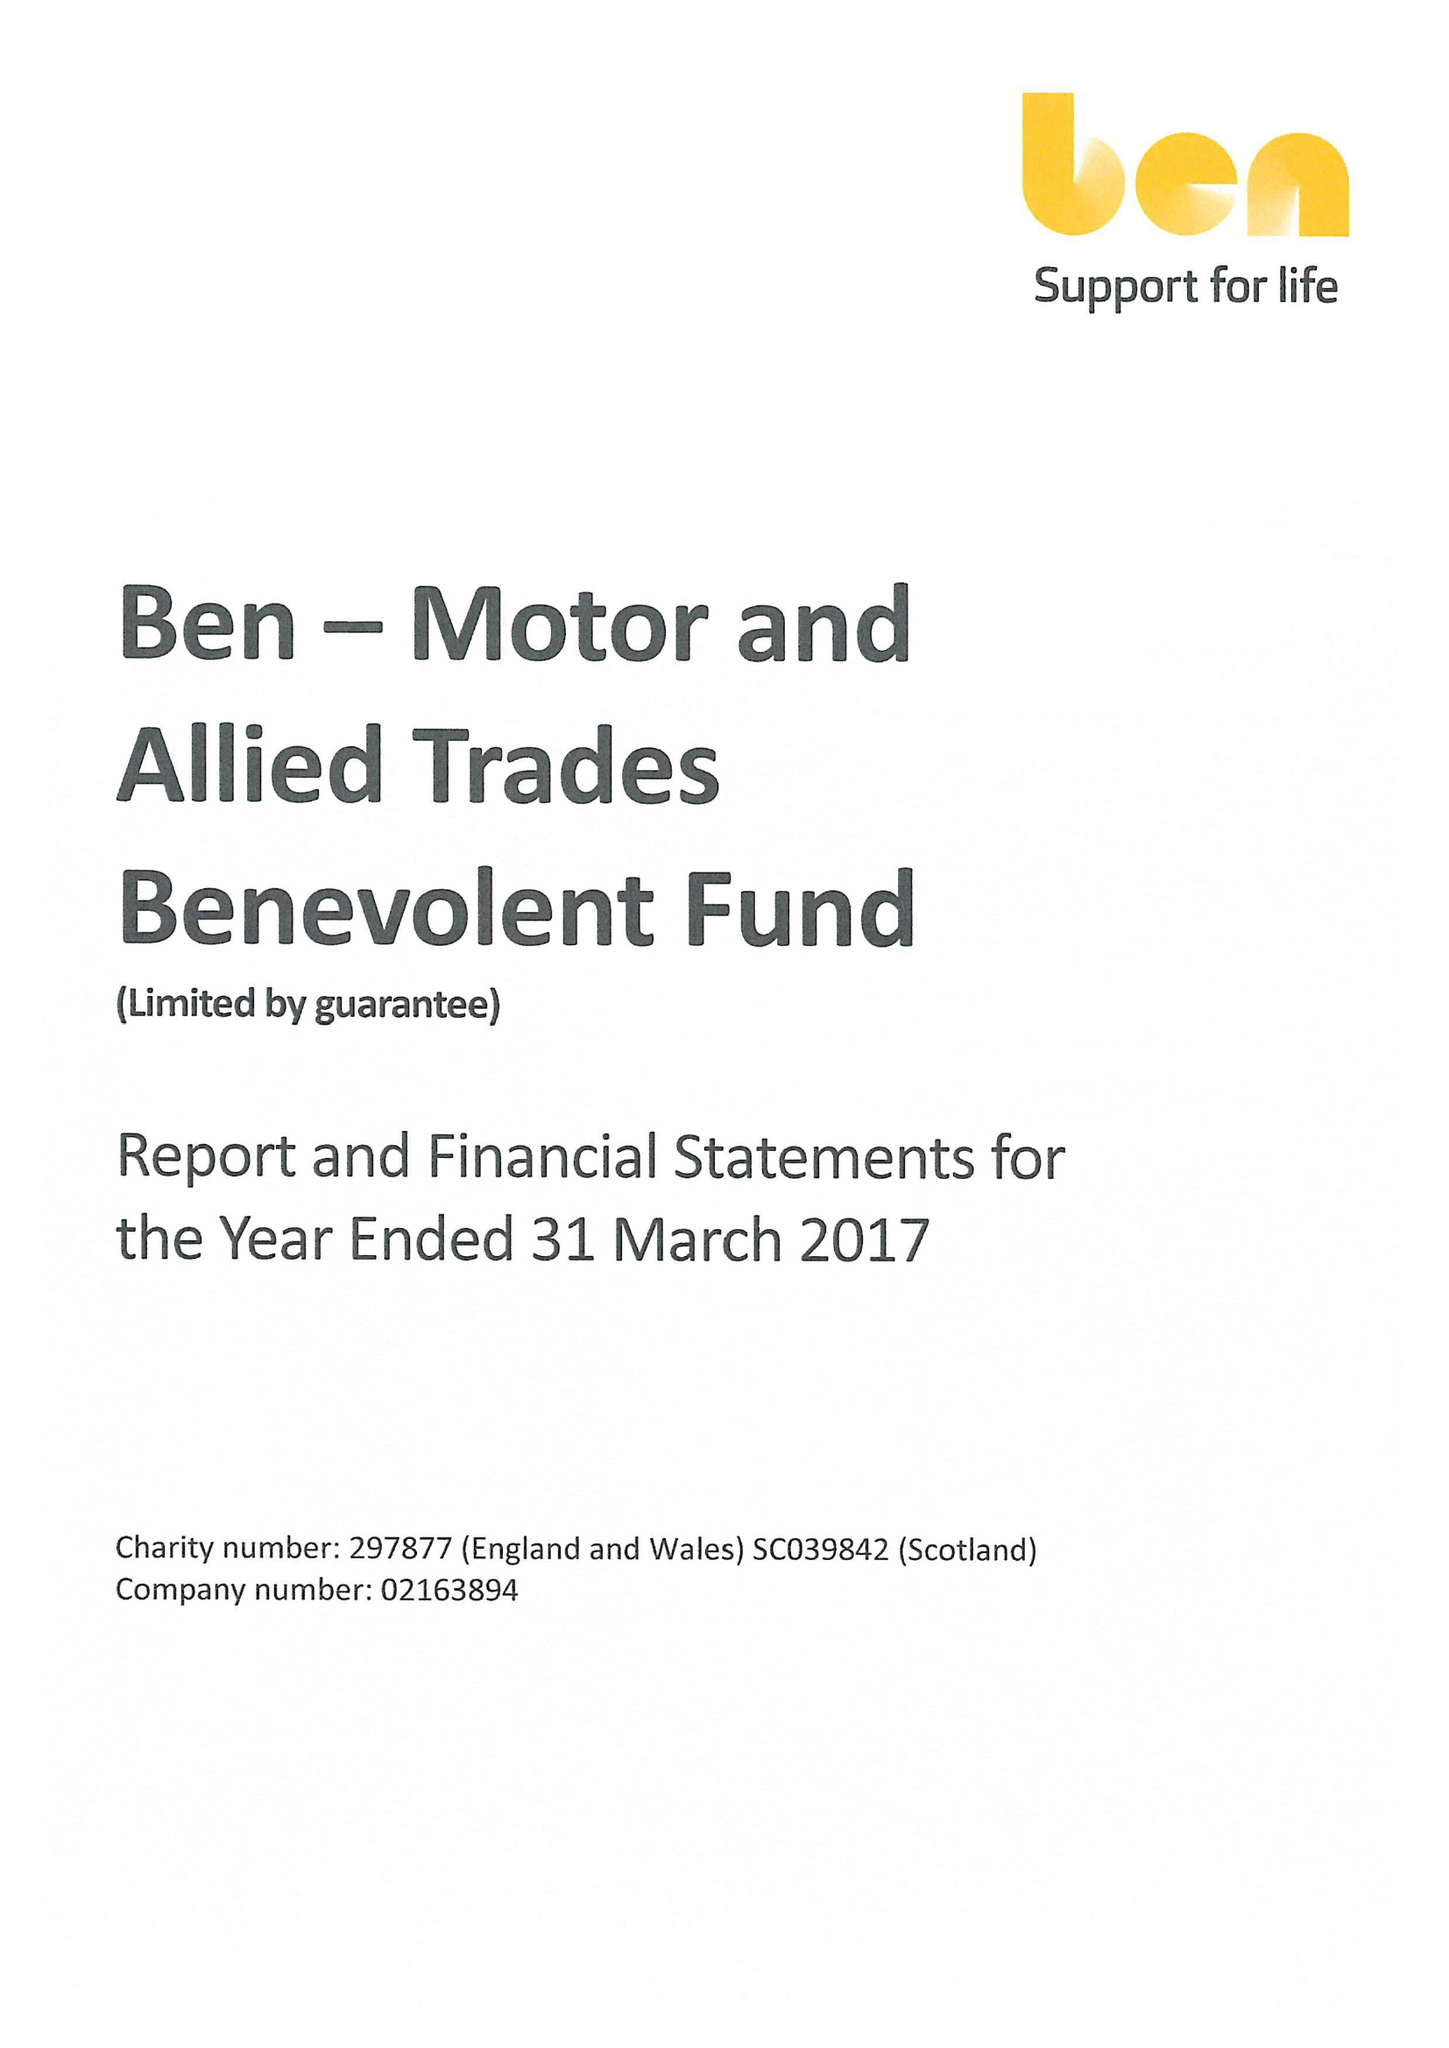What is the value for the charity_number?
Answer the question using a single word or phrase. 297877 